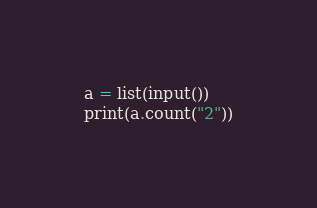Convert code to text. <code><loc_0><loc_0><loc_500><loc_500><_Python_>a = list(input())
print(a.count("2"))</code> 